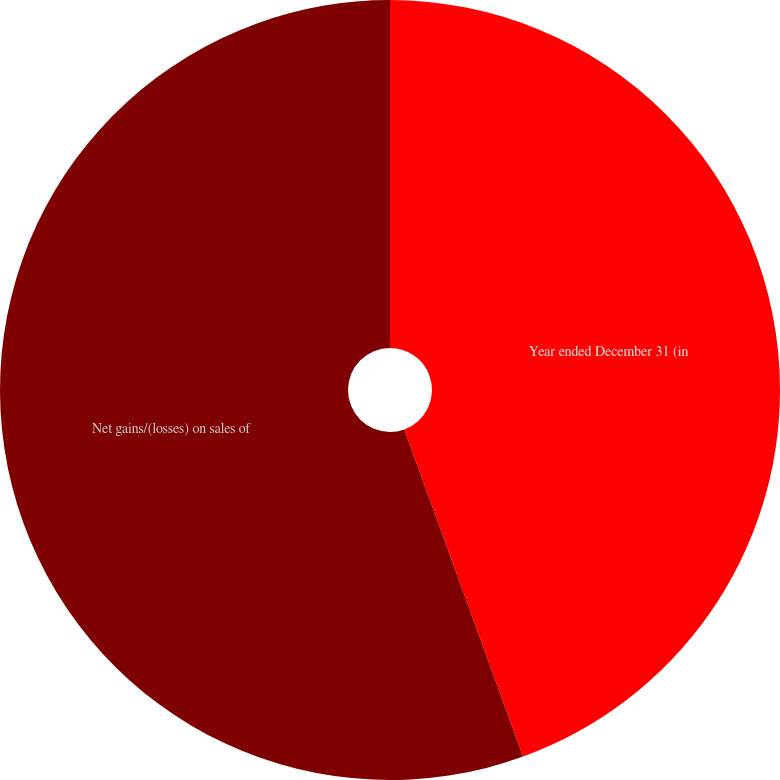Convert chart. <chart><loc_0><loc_0><loc_500><loc_500><pie_chart><fcel>Year ended December 31 (in<fcel>Net gains/(losses) on sales of<nl><fcel>44.46%<fcel>55.54%<nl></chart> 